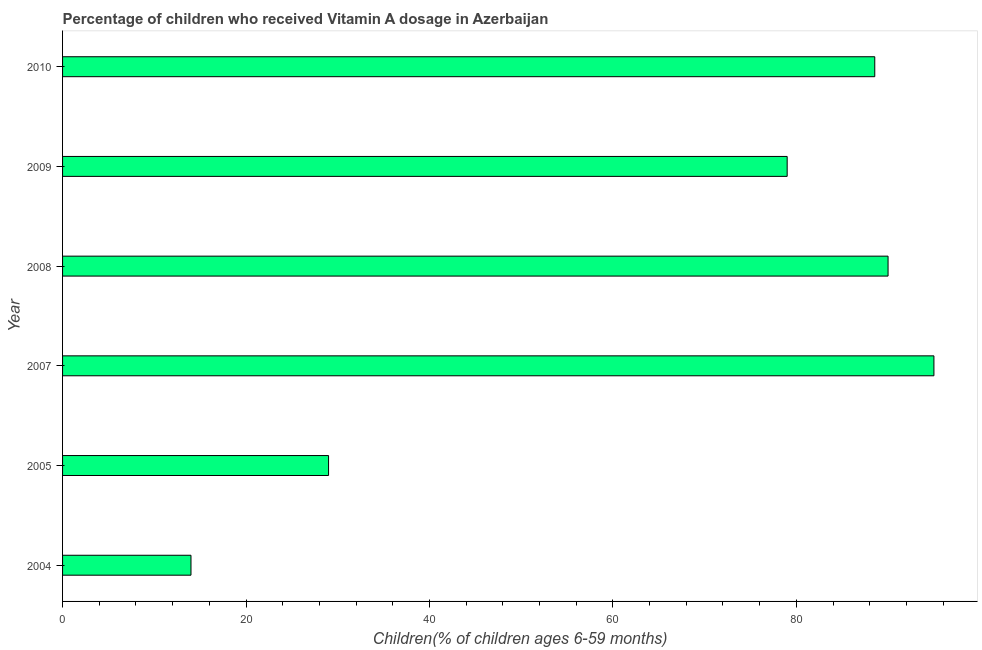Does the graph contain any zero values?
Ensure brevity in your answer.  No. Does the graph contain grids?
Your answer should be compact. No. What is the title of the graph?
Your answer should be compact. Percentage of children who received Vitamin A dosage in Azerbaijan. What is the label or title of the X-axis?
Give a very brief answer. Children(% of children ages 6-59 months). What is the vitamin a supplementation coverage rate in 2004?
Give a very brief answer. 14. In which year was the vitamin a supplementation coverage rate minimum?
Ensure brevity in your answer.  2004. What is the sum of the vitamin a supplementation coverage rate?
Keep it short and to the point. 395.55. What is the difference between the vitamin a supplementation coverage rate in 2004 and 2007?
Your response must be concise. -81. What is the average vitamin a supplementation coverage rate per year?
Make the answer very short. 65.92. What is the median vitamin a supplementation coverage rate?
Offer a terse response. 83.77. In how many years, is the vitamin a supplementation coverage rate greater than 92 %?
Ensure brevity in your answer.  1. Do a majority of the years between 2009 and 2007 (inclusive) have vitamin a supplementation coverage rate greater than 4 %?
Give a very brief answer. Yes. What is the ratio of the vitamin a supplementation coverage rate in 2004 to that in 2008?
Give a very brief answer. 0.16. Are all the bars in the graph horizontal?
Offer a terse response. Yes. Are the values on the major ticks of X-axis written in scientific E-notation?
Give a very brief answer. No. What is the Children(% of children ages 6-59 months) in 2005?
Offer a terse response. 29. What is the Children(% of children ages 6-59 months) of 2007?
Offer a terse response. 95. What is the Children(% of children ages 6-59 months) of 2009?
Keep it short and to the point. 79. What is the Children(% of children ages 6-59 months) of 2010?
Your answer should be very brief. 88.55. What is the difference between the Children(% of children ages 6-59 months) in 2004 and 2005?
Provide a short and direct response. -15. What is the difference between the Children(% of children ages 6-59 months) in 2004 and 2007?
Offer a terse response. -81. What is the difference between the Children(% of children ages 6-59 months) in 2004 and 2008?
Your answer should be compact. -76. What is the difference between the Children(% of children ages 6-59 months) in 2004 and 2009?
Provide a short and direct response. -65. What is the difference between the Children(% of children ages 6-59 months) in 2004 and 2010?
Your answer should be compact. -74.55. What is the difference between the Children(% of children ages 6-59 months) in 2005 and 2007?
Your answer should be very brief. -66. What is the difference between the Children(% of children ages 6-59 months) in 2005 and 2008?
Provide a short and direct response. -61. What is the difference between the Children(% of children ages 6-59 months) in 2005 and 2009?
Your answer should be compact. -50. What is the difference between the Children(% of children ages 6-59 months) in 2005 and 2010?
Provide a succinct answer. -59.55. What is the difference between the Children(% of children ages 6-59 months) in 2007 and 2008?
Provide a succinct answer. 5. What is the difference between the Children(% of children ages 6-59 months) in 2007 and 2009?
Ensure brevity in your answer.  16. What is the difference between the Children(% of children ages 6-59 months) in 2007 and 2010?
Offer a terse response. 6.45. What is the difference between the Children(% of children ages 6-59 months) in 2008 and 2009?
Make the answer very short. 11. What is the difference between the Children(% of children ages 6-59 months) in 2008 and 2010?
Your answer should be very brief. 1.45. What is the difference between the Children(% of children ages 6-59 months) in 2009 and 2010?
Offer a very short reply. -9.55. What is the ratio of the Children(% of children ages 6-59 months) in 2004 to that in 2005?
Give a very brief answer. 0.48. What is the ratio of the Children(% of children ages 6-59 months) in 2004 to that in 2007?
Provide a short and direct response. 0.15. What is the ratio of the Children(% of children ages 6-59 months) in 2004 to that in 2008?
Your response must be concise. 0.16. What is the ratio of the Children(% of children ages 6-59 months) in 2004 to that in 2009?
Give a very brief answer. 0.18. What is the ratio of the Children(% of children ages 6-59 months) in 2004 to that in 2010?
Offer a very short reply. 0.16. What is the ratio of the Children(% of children ages 6-59 months) in 2005 to that in 2007?
Give a very brief answer. 0.3. What is the ratio of the Children(% of children ages 6-59 months) in 2005 to that in 2008?
Provide a short and direct response. 0.32. What is the ratio of the Children(% of children ages 6-59 months) in 2005 to that in 2009?
Offer a terse response. 0.37. What is the ratio of the Children(% of children ages 6-59 months) in 2005 to that in 2010?
Your response must be concise. 0.33. What is the ratio of the Children(% of children ages 6-59 months) in 2007 to that in 2008?
Give a very brief answer. 1.06. What is the ratio of the Children(% of children ages 6-59 months) in 2007 to that in 2009?
Provide a short and direct response. 1.2. What is the ratio of the Children(% of children ages 6-59 months) in 2007 to that in 2010?
Offer a very short reply. 1.07. What is the ratio of the Children(% of children ages 6-59 months) in 2008 to that in 2009?
Your response must be concise. 1.14. What is the ratio of the Children(% of children ages 6-59 months) in 2008 to that in 2010?
Give a very brief answer. 1.02. What is the ratio of the Children(% of children ages 6-59 months) in 2009 to that in 2010?
Offer a terse response. 0.89. 